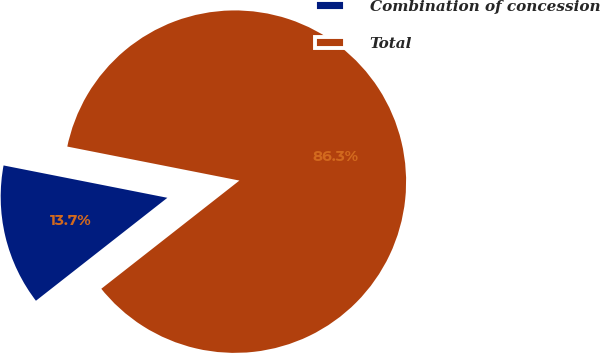Convert chart. <chart><loc_0><loc_0><loc_500><loc_500><pie_chart><fcel>Combination of concession<fcel>Total<nl><fcel>13.68%<fcel>86.32%<nl></chart> 